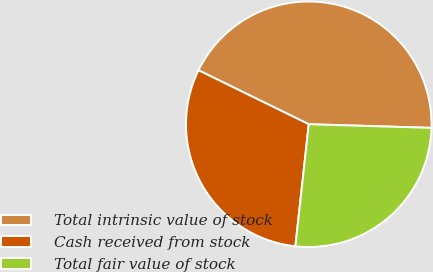Convert chart. <chart><loc_0><loc_0><loc_500><loc_500><pie_chart><fcel>Total intrinsic value of stock<fcel>Cash received from stock<fcel>Total fair value of stock<nl><fcel>43.22%<fcel>30.51%<fcel>26.27%<nl></chart> 